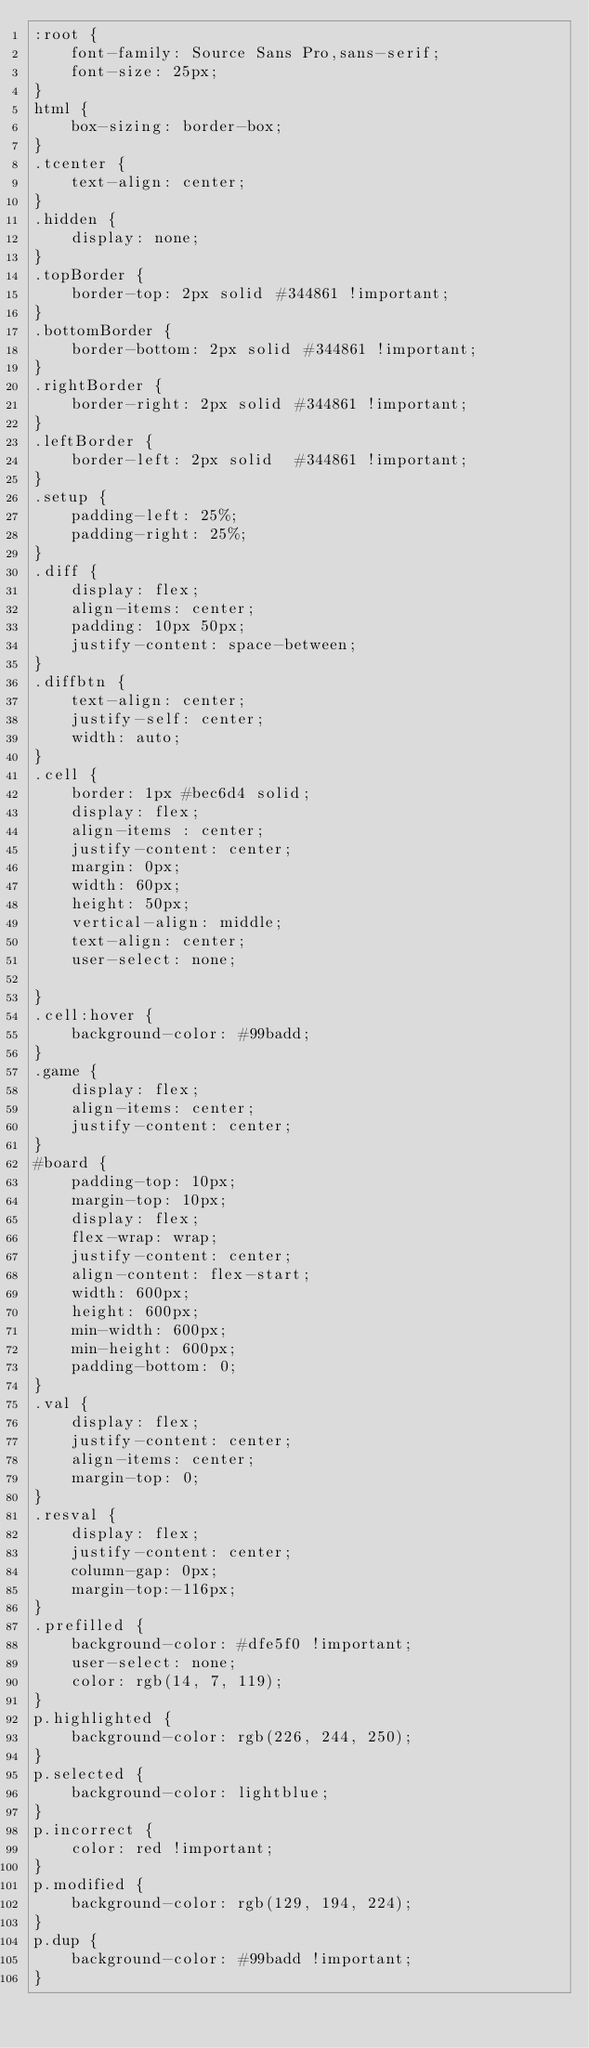<code> <loc_0><loc_0><loc_500><loc_500><_CSS_>:root {
    font-family: Source Sans Pro,sans-serif;
    font-size: 25px;
}
html {
    box-sizing: border-box;
}
.tcenter {
    text-align: center;
}
.hidden {
    display: none;
}
.topBorder {
    border-top: 2px solid #344861 !important;
}
.bottomBorder {
    border-bottom: 2px solid #344861 !important;
}
.rightBorder {
    border-right: 2px solid #344861 !important;
}
.leftBorder {
    border-left: 2px solid  #344861 !important;
}
.setup {
    padding-left: 25%;
    padding-right: 25%;
}
.diff {
    display: flex;
    align-items: center;
    padding: 10px 50px;
    justify-content: space-between;
}
.diffbtn {
    text-align: center;
    justify-self: center;
    width: auto;
}
.cell {
    border: 1px #bec6d4 solid;
    display: flex;
    align-items : center;
    justify-content: center;
    margin: 0px;
    width: 60px;
    height: 50px;
    vertical-align: middle;
    text-align: center;
    user-select: none;

}
.cell:hover {
    background-color: #99badd;
}
.game {
    display: flex;
    align-items: center;
    justify-content: center;
}
#board {
    padding-top: 10px;
    margin-top: 10px;
    display: flex;
    flex-wrap: wrap;
    justify-content: center;
    align-content: flex-start;
    width: 600px;
    height: 600px;
    min-width: 600px;
    min-height: 600px;
    padding-bottom: 0;
}
.val {
    display: flex;
    justify-content: center;
    align-items: center;
    margin-top: 0;
}
.resval {
    display: flex;
    justify-content: center;
    column-gap: 0px;
    margin-top:-116px;
}
.prefilled {
    background-color: #dfe5f0 !important;
    user-select: none;
    color: rgb(14, 7, 119);
}
p.highlighted {
    background-color: rgb(226, 244, 250);
}
p.selected {
    background-color: lightblue;
}
p.incorrect {
    color: red !important;
}
p.modified {
    background-color: rgb(129, 194, 224);
}
p.dup {
    background-color: #99badd !important;
}
</code> 